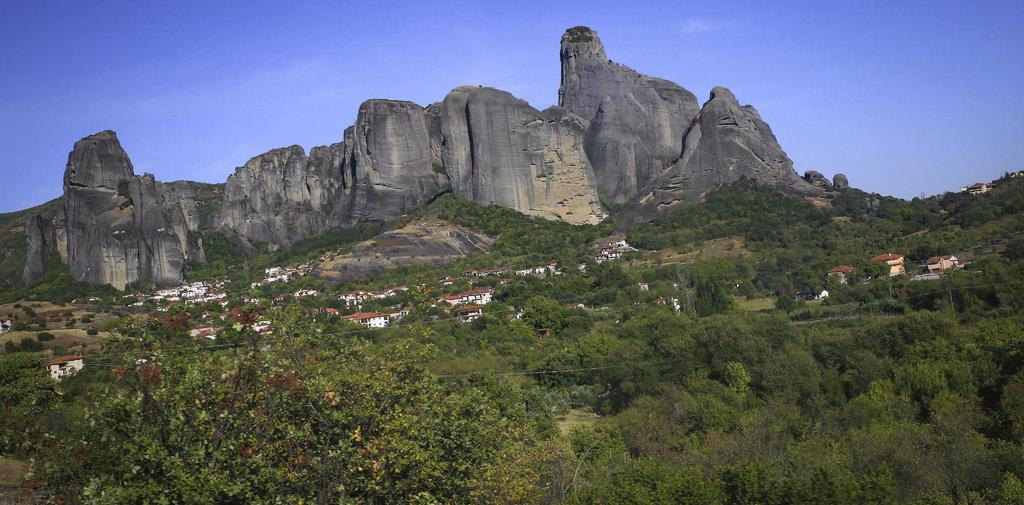What type of natural features can be seen in the image? There are big rocks in the image. What type of man-made structures are present in the image? There are buildings in the image. What type of vegetation is visible in the image? There are trees in the image. Where are the trees located in relation to the mountain in the image? There are trees on a mountain in the image. Can you see your grandmother's toes in the image? There is no reference to a grandmother or toes in the image, so it is not possible to answer that question. 